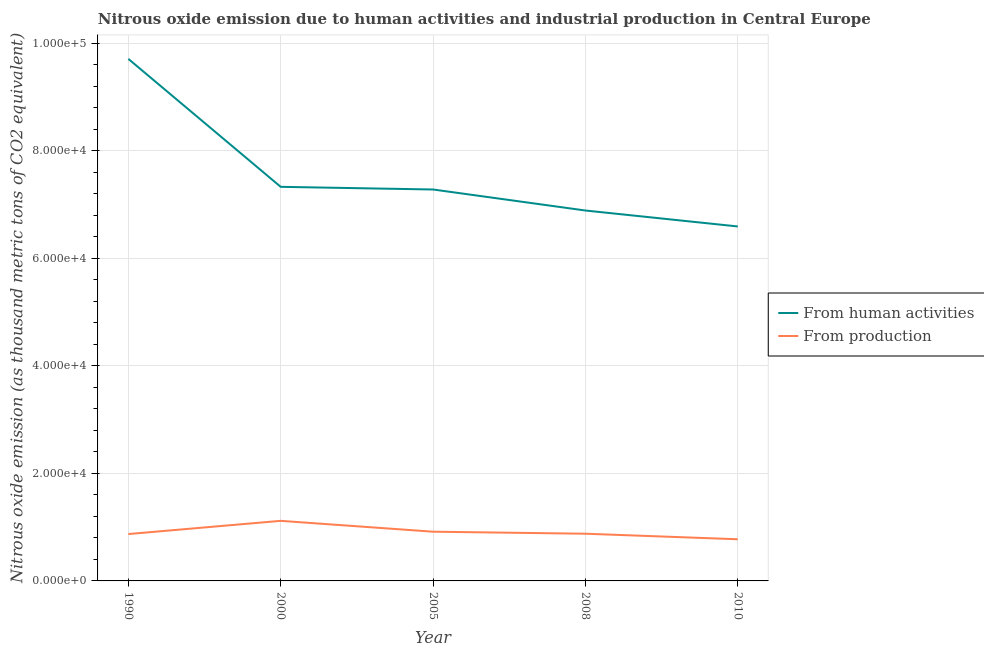Does the line corresponding to amount of emissions generated from industries intersect with the line corresponding to amount of emissions from human activities?
Provide a succinct answer. No. Is the number of lines equal to the number of legend labels?
Provide a short and direct response. Yes. What is the amount of emissions from human activities in 2010?
Ensure brevity in your answer.  6.59e+04. Across all years, what is the maximum amount of emissions generated from industries?
Keep it short and to the point. 1.12e+04. Across all years, what is the minimum amount of emissions generated from industries?
Your answer should be very brief. 7749.3. What is the total amount of emissions from human activities in the graph?
Give a very brief answer. 3.78e+05. What is the difference between the amount of emissions generated from industries in 1990 and that in 2005?
Ensure brevity in your answer.  -435.6. What is the difference between the amount of emissions generated from industries in 2008 and the amount of emissions from human activities in 1990?
Offer a very short reply. -8.83e+04. What is the average amount of emissions from human activities per year?
Keep it short and to the point. 7.56e+04. In the year 2000, what is the difference between the amount of emissions from human activities and amount of emissions generated from industries?
Your answer should be very brief. 6.21e+04. In how many years, is the amount of emissions generated from industries greater than 48000 thousand metric tons?
Ensure brevity in your answer.  0. What is the ratio of the amount of emissions from human activities in 1990 to that in 2000?
Your response must be concise. 1.32. Is the amount of emissions from human activities in 1990 less than that in 2000?
Give a very brief answer. No. What is the difference between the highest and the second highest amount of emissions from human activities?
Provide a succinct answer. 2.38e+04. What is the difference between the highest and the lowest amount of emissions from human activities?
Your response must be concise. 3.12e+04. How many years are there in the graph?
Your answer should be compact. 5. What is the difference between two consecutive major ticks on the Y-axis?
Ensure brevity in your answer.  2.00e+04. Are the values on the major ticks of Y-axis written in scientific E-notation?
Ensure brevity in your answer.  Yes. Does the graph contain any zero values?
Keep it short and to the point. No. Where does the legend appear in the graph?
Your response must be concise. Center right. How are the legend labels stacked?
Your response must be concise. Vertical. What is the title of the graph?
Make the answer very short. Nitrous oxide emission due to human activities and industrial production in Central Europe. Does "Secondary school" appear as one of the legend labels in the graph?
Your answer should be very brief. No. What is the label or title of the Y-axis?
Offer a terse response. Nitrous oxide emission (as thousand metric tons of CO2 equivalent). What is the Nitrous oxide emission (as thousand metric tons of CO2 equivalent) in From human activities in 1990?
Offer a very short reply. 9.71e+04. What is the Nitrous oxide emission (as thousand metric tons of CO2 equivalent) in From production in 1990?
Your answer should be compact. 8719. What is the Nitrous oxide emission (as thousand metric tons of CO2 equivalent) of From human activities in 2000?
Your response must be concise. 7.33e+04. What is the Nitrous oxide emission (as thousand metric tons of CO2 equivalent) of From production in 2000?
Offer a very short reply. 1.12e+04. What is the Nitrous oxide emission (as thousand metric tons of CO2 equivalent) in From human activities in 2005?
Offer a terse response. 7.28e+04. What is the Nitrous oxide emission (as thousand metric tons of CO2 equivalent) of From production in 2005?
Give a very brief answer. 9154.6. What is the Nitrous oxide emission (as thousand metric tons of CO2 equivalent) of From human activities in 2008?
Your answer should be compact. 6.89e+04. What is the Nitrous oxide emission (as thousand metric tons of CO2 equivalent) of From production in 2008?
Offer a very short reply. 8781. What is the Nitrous oxide emission (as thousand metric tons of CO2 equivalent) of From human activities in 2010?
Give a very brief answer. 6.59e+04. What is the Nitrous oxide emission (as thousand metric tons of CO2 equivalent) of From production in 2010?
Provide a succinct answer. 7749.3. Across all years, what is the maximum Nitrous oxide emission (as thousand metric tons of CO2 equivalent) in From human activities?
Your answer should be compact. 9.71e+04. Across all years, what is the maximum Nitrous oxide emission (as thousand metric tons of CO2 equivalent) in From production?
Make the answer very short. 1.12e+04. Across all years, what is the minimum Nitrous oxide emission (as thousand metric tons of CO2 equivalent) of From human activities?
Provide a succinct answer. 6.59e+04. Across all years, what is the minimum Nitrous oxide emission (as thousand metric tons of CO2 equivalent) in From production?
Offer a terse response. 7749.3. What is the total Nitrous oxide emission (as thousand metric tons of CO2 equivalent) of From human activities in the graph?
Your response must be concise. 3.78e+05. What is the total Nitrous oxide emission (as thousand metric tons of CO2 equivalent) in From production in the graph?
Your answer should be very brief. 4.56e+04. What is the difference between the Nitrous oxide emission (as thousand metric tons of CO2 equivalent) in From human activities in 1990 and that in 2000?
Make the answer very short. 2.38e+04. What is the difference between the Nitrous oxide emission (as thousand metric tons of CO2 equivalent) in From production in 1990 and that in 2000?
Your response must be concise. -2457.2. What is the difference between the Nitrous oxide emission (as thousand metric tons of CO2 equivalent) of From human activities in 1990 and that in 2005?
Ensure brevity in your answer.  2.43e+04. What is the difference between the Nitrous oxide emission (as thousand metric tons of CO2 equivalent) in From production in 1990 and that in 2005?
Offer a very short reply. -435.6. What is the difference between the Nitrous oxide emission (as thousand metric tons of CO2 equivalent) of From human activities in 1990 and that in 2008?
Offer a terse response. 2.82e+04. What is the difference between the Nitrous oxide emission (as thousand metric tons of CO2 equivalent) in From production in 1990 and that in 2008?
Your answer should be compact. -62. What is the difference between the Nitrous oxide emission (as thousand metric tons of CO2 equivalent) in From human activities in 1990 and that in 2010?
Provide a short and direct response. 3.12e+04. What is the difference between the Nitrous oxide emission (as thousand metric tons of CO2 equivalent) in From production in 1990 and that in 2010?
Give a very brief answer. 969.7. What is the difference between the Nitrous oxide emission (as thousand metric tons of CO2 equivalent) of From human activities in 2000 and that in 2005?
Provide a short and direct response. 496.7. What is the difference between the Nitrous oxide emission (as thousand metric tons of CO2 equivalent) of From production in 2000 and that in 2005?
Your answer should be compact. 2021.6. What is the difference between the Nitrous oxide emission (as thousand metric tons of CO2 equivalent) in From human activities in 2000 and that in 2008?
Your answer should be very brief. 4407. What is the difference between the Nitrous oxide emission (as thousand metric tons of CO2 equivalent) of From production in 2000 and that in 2008?
Provide a succinct answer. 2395.2. What is the difference between the Nitrous oxide emission (as thousand metric tons of CO2 equivalent) of From human activities in 2000 and that in 2010?
Provide a short and direct response. 7373.8. What is the difference between the Nitrous oxide emission (as thousand metric tons of CO2 equivalent) in From production in 2000 and that in 2010?
Your response must be concise. 3426.9. What is the difference between the Nitrous oxide emission (as thousand metric tons of CO2 equivalent) in From human activities in 2005 and that in 2008?
Your answer should be compact. 3910.3. What is the difference between the Nitrous oxide emission (as thousand metric tons of CO2 equivalent) in From production in 2005 and that in 2008?
Your answer should be very brief. 373.6. What is the difference between the Nitrous oxide emission (as thousand metric tons of CO2 equivalent) in From human activities in 2005 and that in 2010?
Your answer should be compact. 6877.1. What is the difference between the Nitrous oxide emission (as thousand metric tons of CO2 equivalent) in From production in 2005 and that in 2010?
Your response must be concise. 1405.3. What is the difference between the Nitrous oxide emission (as thousand metric tons of CO2 equivalent) in From human activities in 2008 and that in 2010?
Your answer should be compact. 2966.8. What is the difference between the Nitrous oxide emission (as thousand metric tons of CO2 equivalent) in From production in 2008 and that in 2010?
Offer a terse response. 1031.7. What is the difference between the Nitrous oxide emission (as thousand metric tons of CO2 equivalent) in From human activities in 1990 and the Nitrous oxide emission (as thousand metric tons of CO2 equivalent) in From production in 2000?
Your answer should be compact. 8.59e+04. What is the difference between the Nitrous oxide emission (as thousand metric tons of CO2 equivalent) in From human activities in 1990 and the Nitrous oxide emission (as thousand metric tons of CO2 equivalent) in From production in 2005?
Your response must be concise. 8.80e+04. What is the difference between the Nitrous oxide emission (as thousand metric tons of CO2 equivalent) in From human activities in 1990 and the Nitrous oxide emission (as thousand metric tons of CO2 equivalent) in From production in 2008?
Provide a short and direct response. 8.83e+04. What is the difference between the Nitrous oxide emission (as thousand metric tons of CO2 equivalent) in From human activities in 1990 and the Nitrous oxide emission (as thousand metric tons of CO2 equivalent) in From production in 2010?
Your answer should be compact. 8.94e+04. What is the difference between the Nitrous oxide emission (as thousand metric tons of CO2 equivalent) of From human activities in 2000 and the Nitrous oxide emission (as thousand metric tons of CO2 equivalent) of From production in 2005?
Give a very brief answer. 6.42e+04. What is the difference between the Nitrous oxide emission (as thousand metric tons of CO2 equivalent) of From human activities in 2000 and the Nitrous oxide emission (as thousand metric tons of CO2 equivalent) of From production in 2008?
Offer a terse response. 6.45e+04. What is the difference between the Nitrous oxide emission (as thousand metric tons of CO2 equivalent) of From human activities in 2000 and the Nitrous oxide emission (as thousand metric tons of CO2 equivalent) of From production in 2010?
Your answer should be compact. 6.56e+04. What is the difference between the Nitrous oxide emission (as thousand metric tons of CO2 equivalent) of From human activities in 2005 and the Nitrous oxide emission (as thousand metric tons of CO2 equivalent) of From production in 2008?
Ensure brevity in your answer.  6.40e+04. What is the difference between the Nitrous oxide emission (as thousand metric tons of CO2 equivalent) of From human activities in 2005 and the Nitrous oxide emission (as thousand metric tons of CO2 equivalent) of From production in 2010?
Your answer should be compact. 6.51e+04. What is the difference between the Nitrous oxide emission (as thousand metric tons of CO2 equivalent) of From human activities in 2008 and the Nitrous oxide emission (as thousand metric tons of CO2 equivalent) of From production in 2010?
Ensure brevity in your answer.  6.12e+04. What is the average Nitrous oxide emission (as thousand metric tons of CO2 equivalent) of From human activities per year?
Your answer should be compact. 7.56e+04. What is the average Nitrous oxide emission (as thousand metric tons of CO2 equivalent) in From production per year?
Keep it short and to the point. 9116.02. In the year 1990, what is the difference between the Nitrous oxide emission (as thousand metric tons of CO2 equivalent) of From human activities and Nitrous oxide emission (as thousand metric tons of CO2 equivalent) of From production?
Give a very brief answer. 8.84e+04. In the year 2000, what is the difference between the Nitrous oxide emission (as thousand metric tons of CO2 equivalent) of From human activities and Nitrous oxide emission (as thousand metric tons of CO2 equivalent) of From production?
Your response must be concise. 6.21e+04. In the year 2005, what is the difference between the Nitrous oxide emission (as thousand metric tons of CO2 equivalent) in From human activities and Nitrous oxide emission (as thousand metric tons of CO2 equivalent) in From production?
Keep it short and to the point. 6.37e+04. In the year 2008, what is the difference between the Nitrous oxide emission (as thousand metric tons of CO2 equivalent) in From human activities and Nitrous oxide emission (as thousand metric tons of CO2 equivalent) in From production?
Your response must be concise. 6.01e+04. In the year 2010, what is the difference between the Nitrous oxide emission (as thousand metric tons of CO2 equivalent) of From human activities and Nitrous oxide emission (as thousand metric tons of CO2 equivalent) of From production?
Offer a terse response. 5.82e+04. What is the ratio of the Nitrous oxide emission (as thousand metric tons of CO2 equivalent) in From human activities in 1990 to that in 2000?
Keep it short and to the point. 1.32. What is the ratio of the Nitrous oxide emission (as thousand metric tons of CO2 equivalent) of From production in 1990 to that in 2000?
Keep it short and to the point. 0.78. What is the ratio of the Nitrous oxide emission (as thousand metric tons of CO2 equivalent) in From human activities in 1990 to that in 2005?
Your answer should be very brief. 1.33. What is the ratio of the Nitrous oxide emission (as thousand metric tons of CO2 equivalent) of From production in 1990 to that in 2005?
Give a very brief answer. 0.95. What is the ratio of the Nitrous oxide emission (as thousand metric tons of CO2 equivalent) of From human activities in 1990 to that in 2008?
Keep it short and to the point. 1.41. What is the ratio of the Nitrous oxide emission (as thousand metric tons of CO2 equivalent) in From production in 1990 to that in 2008?
Your answer should be very brief. 0.99. What is the ratio of the Nitrous oxide emission (as thousand metric tons of CO2 equivalent) of From human activities in 1990 to that in 2010?
Your answer should be very brief. 1.47. What is the ratio of the Nitrous oxide emission (as thousand metric tons of CO2 equivalent) in From production in 1990 to that in 2010?
Provide a short and direct response. 1.13. What is the ratio of the Nitrous oxide emission (as thousand metric tons of CO2 equivalent) in From human activities in 2000 to that in 2005?
Make the answer very short. 1.01. What is the ratio of the Nitrous oxide emission (as thousand metric tons of CO2 equivalent) of From production in 2000 to that in 2005?
Your answer should be very brief. 1.22. What is the ratio of the Nitrous oxide emission (as thousand metric tons of CO2 equivalent) of From human activities in 2000 to that in 2008?
Provide a succinct answer. 1.06. What is the ratio of the Nitrous oxide emission (as thousand metric tons of CO2 equivalent) of From production in 2000 to that in 2008?
Your answer should be very brief. 1.27. What is the ratio of the Nitrous oxide emission (as thousand metric tons of CO2 equivalent) in From human activities in 2000 to that in 2010?
Your answer should be very brief. 1.11. What is the ratio of the Nitrous oxide emission (as thousand metric tons of CO2 equivalent) in From production in 2000 to that in 2010?
Provide a short and direct response. 1.44. What is the ratio of the Nitrous oxide emission (as thousand metric tons of CO2 equivalent) of From human activities in 2005 to that in 2008?
Ensure brevity in your answer.  1.06. What is the ratio of the Nitrous oxide emission (as thousand metric tons of CO2 equivalent) of From production in 2005 to that in 2008?
Offer a terse response. 1.04. What is the ratio of the Nitrous oxide emission (as thousand metric tons of CO2 equivalent) of From human activities in 2005 to that in 2010?
Offer a terse response. 1.1. What is the ratio of the Nitrous oxide emission (as thousand metric tons of CO2 equivalent) of From production in 2005 to that in 2010?
Your response must be concise. 1.18. What is the ratio of the Nitrous oxide emission (as thousand metric tons of CO2 equivalent) of From human activities in 2008 to that in 2010?
Provide a short and direct response. 1.04. What is the ratio of the Nitrous oxide emission (as thousand metric tons of CO2 equivalent) in From production in 2008 to that in 2010?
Your answer should be compact. 1.13. What is the difference between the highest and the second highest Nitrous oxide emission (as thousand metric tons of CO2 equivalent) in From human activities?
Offer a very short reply. 2.38e+04. What is the difference between the highest and the second highest Nitrous oxide emission (as thousand metric tons of CO2 equivalent) in From production?
Your response must be concise. 2021.6. What is the difference between the highest and the lowest Nitrous oxide emission (as thousand metric tons of CO2 equivalent) in From human activities?
Keep it short and to the point. 3.12e+04. What is the difference between the highest and the lowest Nitrous oxide emission (as thousand metric tons of CO2 equivalent) of From production?
Keep it short and to the point. 3426.9. 